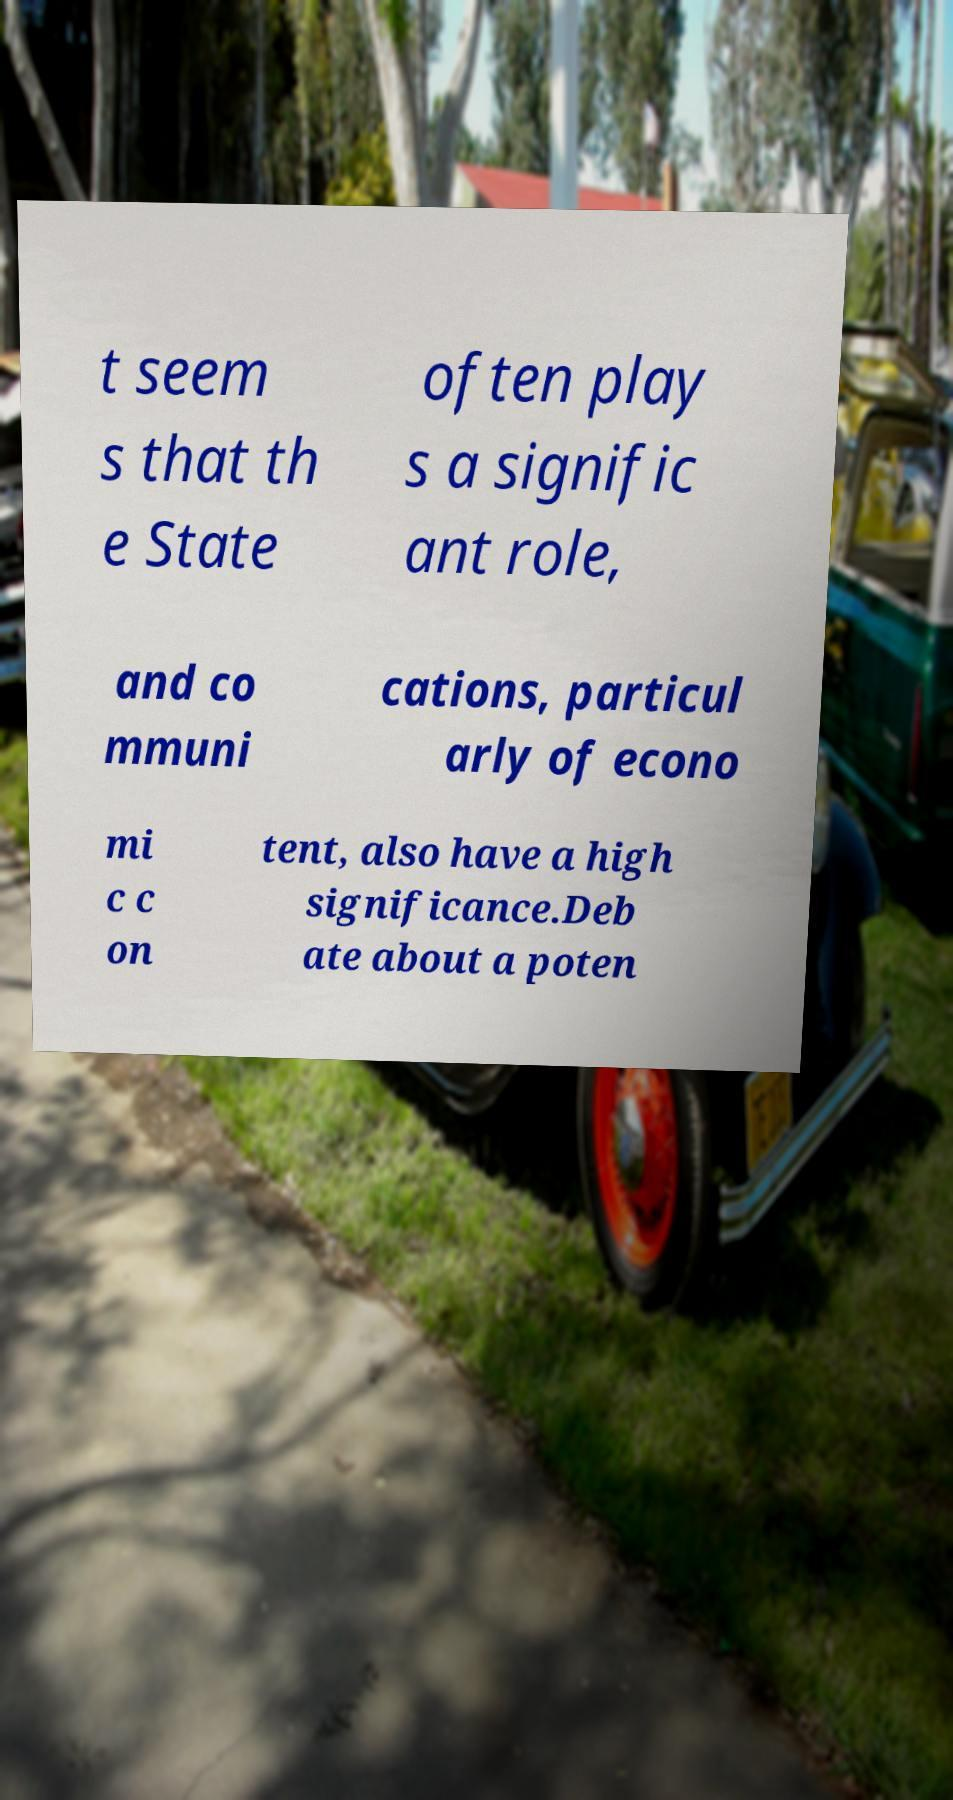Please read and relay the text visible in this image. What does it say? t seem s that th e State often play s a signific ant role, and co mmuni cations, particul arly of econo mi c c on tent, also have a high significance.Deb ate about a poten 